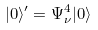<formula> <loc_0><loc_0><loc_500><loc_500>| 0 \rangle ^ { \prime } = \Psi ^ { 4 } _ { \nu } | 0 \rangle</formula> 